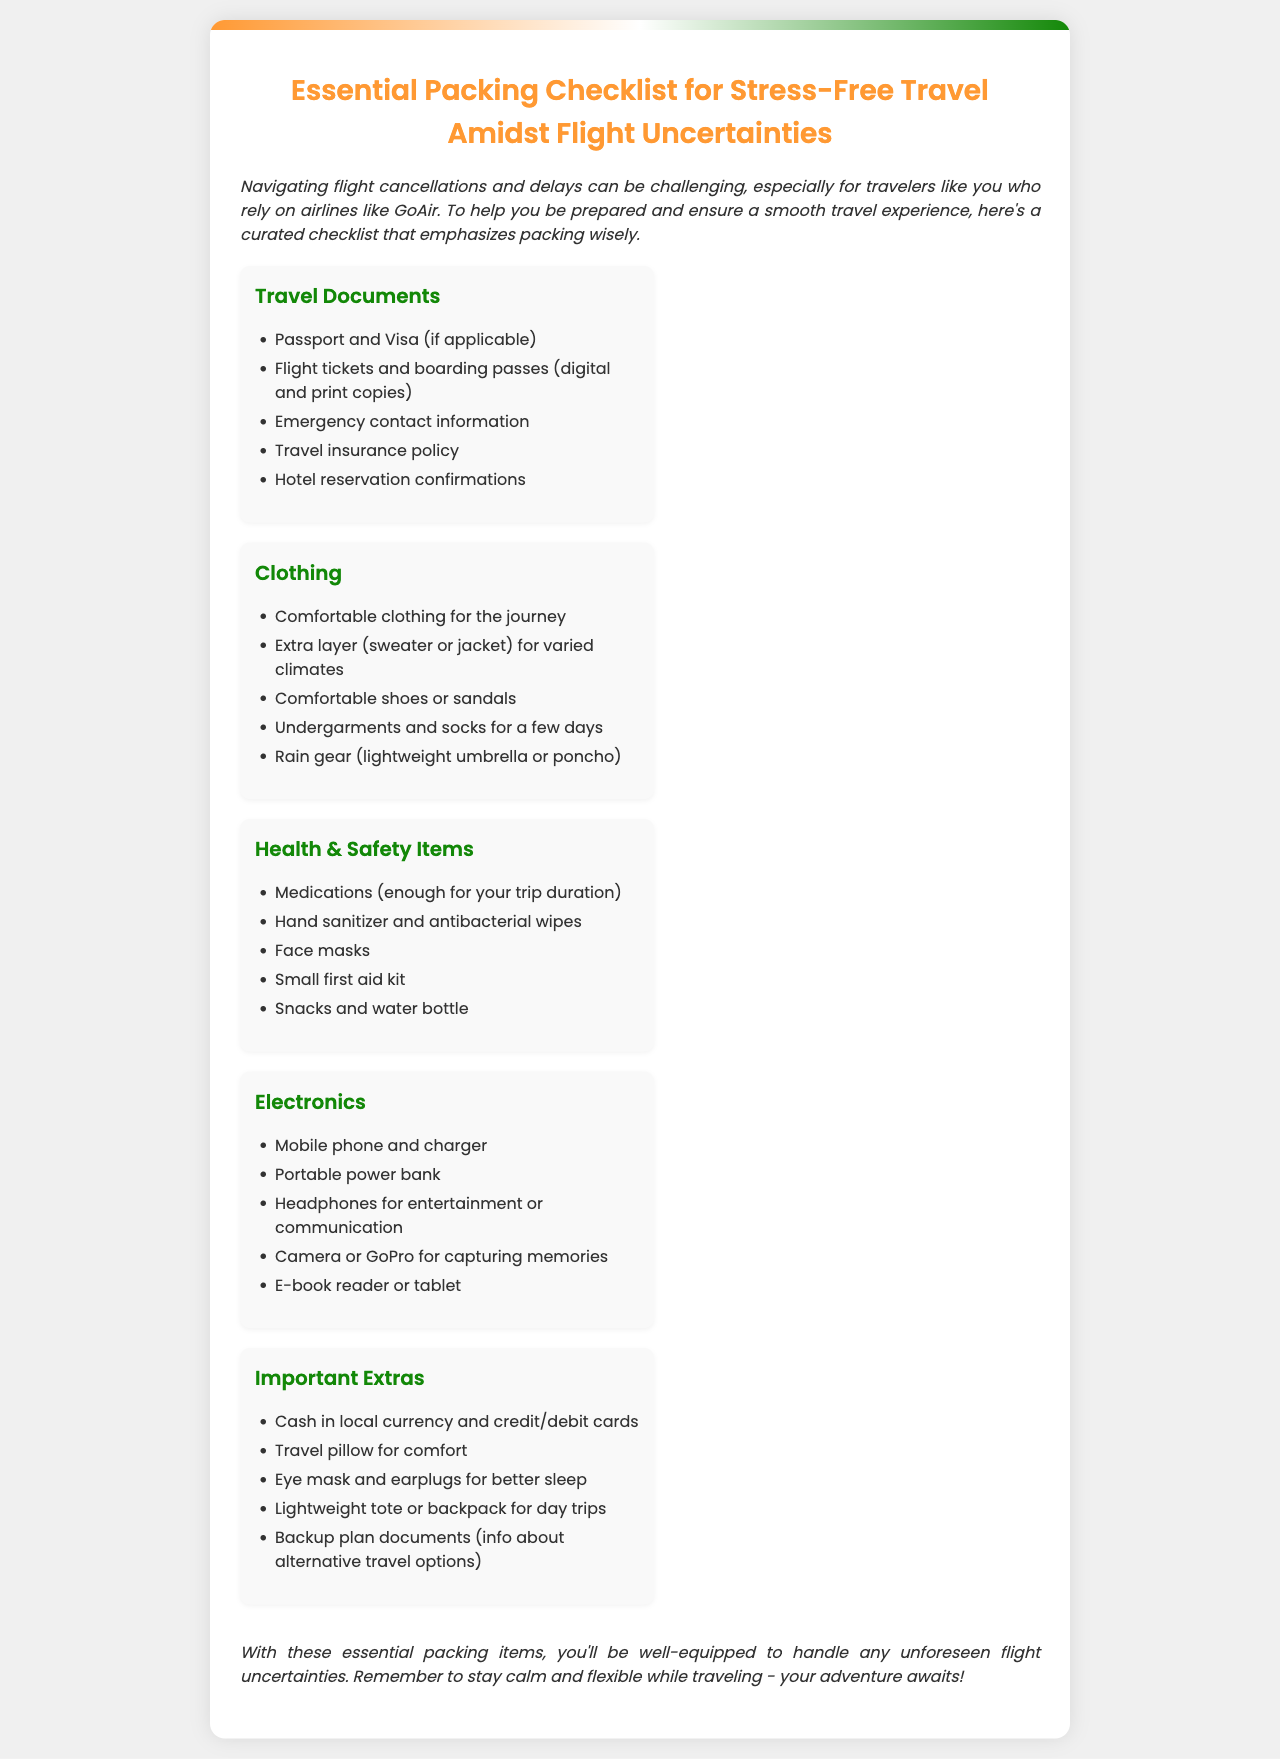What is the title of the document? The title of the document is presented prominently at the top and describes the main focus of the brochure.
Answer: Essential Packing Checklist for Stress-Free Travel Amidst Flight Uncertainties How many categories are included in the checklist? The number of categories can be counted from the overview section of the checklist provided in the document.
Answer: Five What is one of the travel documents recommended to pack? The document lists several essential travel documents in the first category of the checklist.
Answer: Passport and Visa (if applicable) What health item should you carry for sanitation? The section on health and safety items specifies key items for hygiene during travel.
Answer: Hand sanitizer and antibacterial wipes What item is suggested for comfort during the journey? The document includes recommendations for comfort in the "Important Extras" section of the checklist.
Answer: Travel pillow for comfort Which electronics are advised to bring? The electronics section of the checklist mentions items that are essential for travel convenience.
Answer: Mobile phone and charger What should be included in the backup plan documents? The conclusion points to the importance of having information regarding alternative travel options.
Answer: Info about alternative travel options What type of footwear is recommended for comfort? The clothing section of the checklist specifies types of shoes that should be comfortable for travel.
Answer: Comfortable shoes or sandals What is a key piece of advice for handling flight uncertainties? The conclusion section emphasizes maintaining a certain mindset while traveling and addressing potential issues.
Answer: Stay calm and flexible 